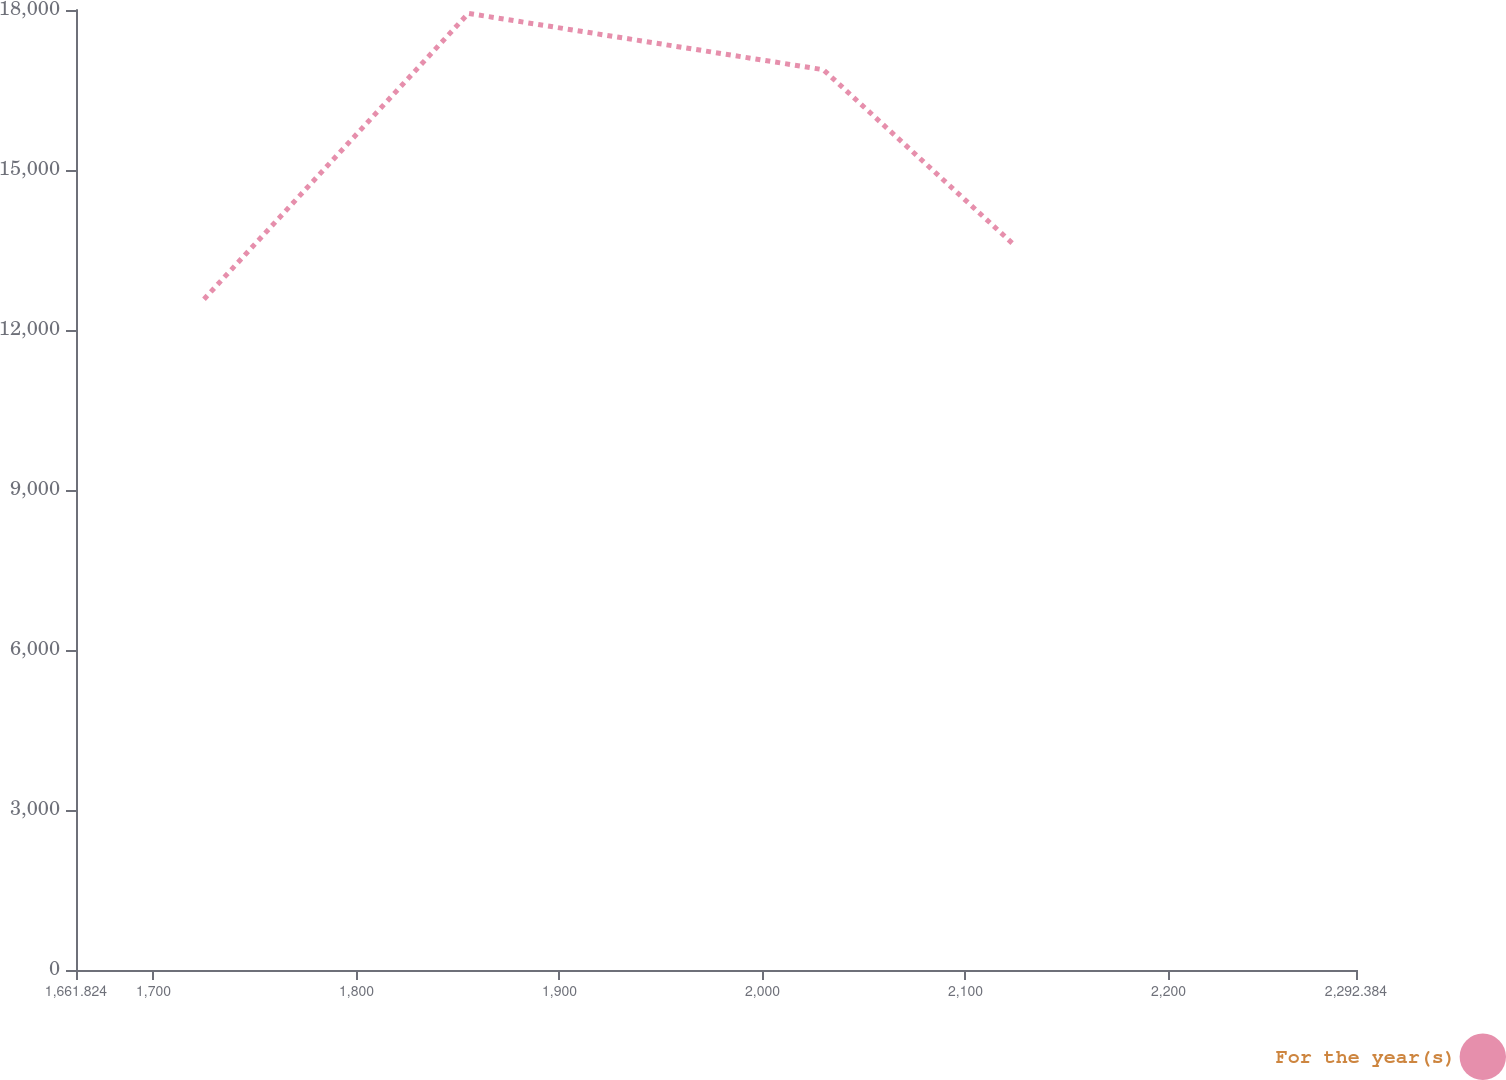Convert chart to OTSL. <chart><loc_0><loc_0><loc_500><loc_500><line_chart><ecel><fcel>For the year(s)<nl><fcel>1724.88<fcel>12577.7<nl><fcel>1855.1<fcel>17936.3<nl><fcel>2030<fcel>16880.1<nl><fcel>2123.42<fcel>13614.6<nl><fcel>2355.44<fcel>17408.2<nl></chart> 